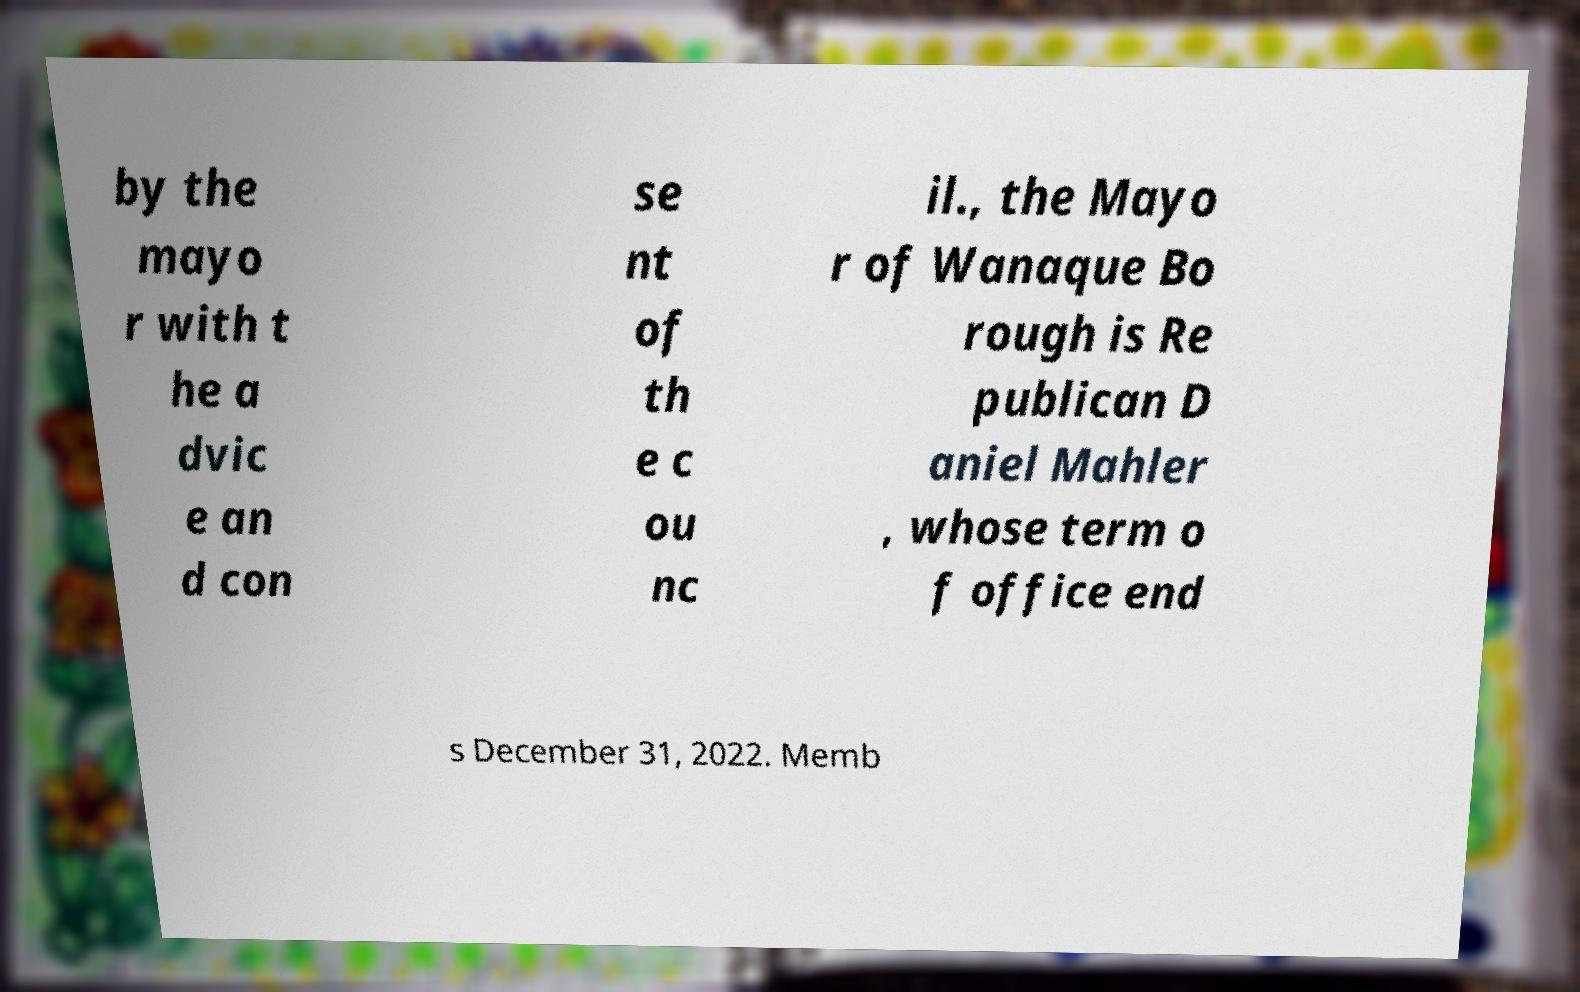Can you read and provide the text displayed in the image?This photo seems to have some interesting text. Can you extract and type it out for me? by the mayo r with t he a dvic e an d con se nt of th e c ou nc il., the Mayo r of Wanaque Bo rough is Re publican D aniel Mahler , whose term o f office end s December 31, 2022. Memb 